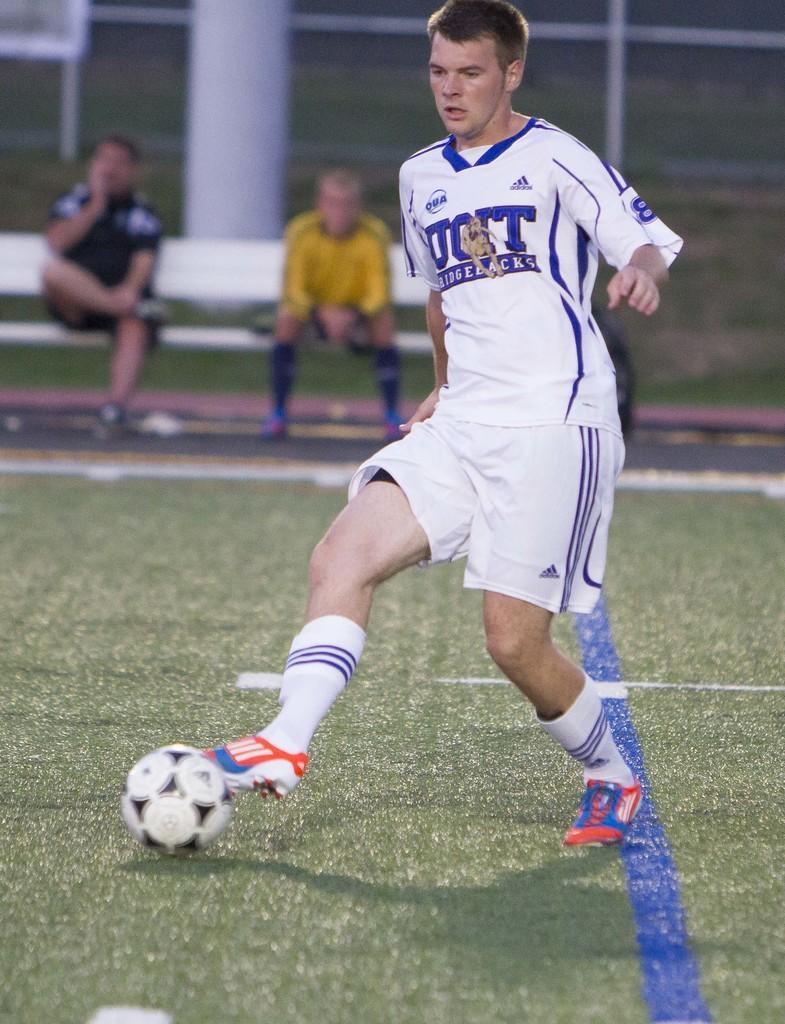Could you give a brief overview of what you see in this image? Here we can see a man is running on the ground, and her is the ball, and at back here the people are sitting. 